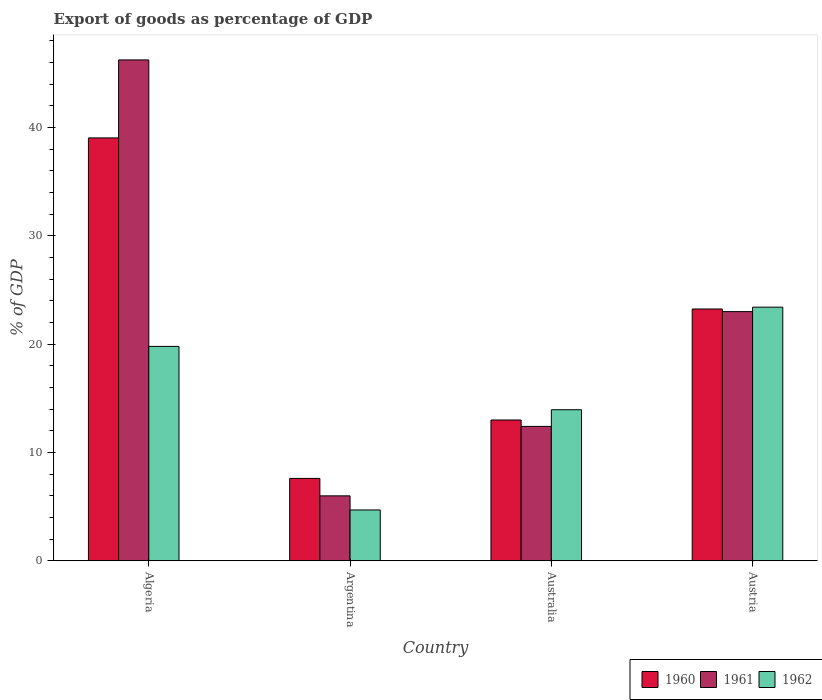How many different coloured bars are there?
Make the answer very short. 3. How many groups of bars are there?
Offer a terse response. 4. Are the number of bars per tick equal to the number of legend labels?
Provide a succinct answer. Yes. Are the number of bars on each tick of the X-axis equal?
Give a very brief answer. Yes. How many bars are there on the 4th tick from the right?
Keep it short and to the point. 3. What is the label of the 1st group of bars from the left?
Make the answer very short. Algeria. What is the export of goods as percentage of GDP in 1961 in Austria?
Ensure brevity in your answer.  23.01. Across all countries, what is the maximum export of goods as percentage of GDP in 1960?
Offer a terse response. 39.04. Across all countries, what is the minimum export of goods as percentage of GDP in 1960?
Keep it short and to the point. 7.6. In which country was the export of goods as percentage of GDP in 1960 maximum?
Offer a very short reply. Algeria. What is the total export of goods as percentage of GDP in 1961 in the graph?
Your response must be concise. 87.65. What is the difference between the export of goods as percentage of GDP in 1960 in Australia and that in Austria?
Make the answer very short. -10.25. What is the difference between the export of goods as percentage of GDP in 1960 in Australia and the export of goods as percentage of GDP in 1962 in Austria?
Make the answer very short. -10.42. What is the average export of goods as percentage of GDP in 1962 per country?
Your answer should be compact. 15.46. What is the difference between the export of goods as percentage of GDP of/in 1961 and export of goods as percentage of GDP of/in 1960 in Algeria?
Offer a terse response. 7.2. In how many countries, is the export of goods as percentage of GDP in 1960 greater than 16 %?
Provide a short and direct response. 2. What is the ratio of the export of goods as percentage of GDP in 1961 in Algeria to that in Austria?
Your answer should be very brief. 2.01. Is the export of goods as percentage of GDP in 1961 in Argentina less than that in Austria?
Your answer should be compact. Yes. Is the difference between the export of goods as percentage of GDP in 1961 in Australia and Austria greater than the difference between the export of goods as percentage of GDP in 1960 in Australia and Austria?
Offer a very short reply. No. What is the difference between the highest and the second highest export of goods as percentage of GDP in 1962?
Your response must be concise. 5.85. What is the difference between the highest and the lowest export of goods as percentage of GDP in 1961?
Offer a very short reply. 40.25. In how many countries, is the export of goods as percentage of GDP in 1962 greater than the average export of goods as percentage of GDP in 1962 taken over all countries?
Provide a short and direct response. 2. Is the sum of the export of goods as percentage of GDP in 1961 in Algeria and Australia greater than the maximum export of goods as percentage of GDP in 1962 across all countries?
Provide a short and direct response. Yes. What does the 3rd bar from the left in Argentina represents?
Ensure brevity in your answer.  1962. Is it the case that in every country, the sum of the export of goods as percentage of GDP in 1961 and export of goods as percentage of GDP in 1960 is greater than the export of goods as percentage of GDP in 1962?
Make the answer very short. Yes. How many bars are there?
Offer a terse response. 12. Are all the bars in the graph horizontal?
Make the answer very short. No. How many countries are there in the graph?
Make the answer very short. 4. Are the values on the major ticks of Y-axis written in scientific E-notation?
Your answer should be very brief. No. Does the graph contain grids?
Provide a short and direct response. No. Where does the legend appear in the graph?
Your answer should be compact. Bottom right. How many legend labels are there?
Ensure brevity in your answer.  3. How are the legend labels stacked?
Provide a succinct answer. Horizontal. What is the title of the graph?
Give a very brief answer. Export of goods as percentage of GDP. What is the label or title of the X-axis?
Provide a succinct answer. Country. What is the label or title of the Y-axis?
Give a very brief answer. % of GDP. What is the % of GDP in 1960 in Algeria?
Provide a short and direct response. 39.04. What is the % of GDP of 1961 in Algeria?
Provide a short and direct response. 46.24. What is the % of GDP of 1962 in Algeria?
Ensure brevity in your answer.  19.79. What is the % of GDP in 1960 in Argentina?
Your answer should be compact. 7.6. What is the % of GDP of 1961 in Argentina?
Ensure brevity in your answer.  5.99. What is the % of GDP of 1962 in Argentina?
Make the answer very short. 4.69. What is the % of GDP in 1960 in Australia?
Offer a very short reply. 13. What is the % of GDP in 1961 in Australia?
Keep it short and to the point. 12.41. What is the % of GDP of 1962 in Australia?
Your response must be concise. 13.95. What is the % of GDP in 1960 in Austria?
Make the answer very short. 23.25. What is the % of GDP of 1961 in Austria?
Give a very brief answer. 23.01. What is the % of GDP of 1962 in Austria?
Provide a short and direct response. 23.42. Across all countries, what is the maximum % of GDP of 1960?
Offer a terse response. 39.04. Across all countries, what is the maximum % of GDP of 1961?
Offer a terse response. 46.24. Across all countries, what is the maximum % of GDP of 1962?
Keep it short and to the point. 23.42. Across all countries, what is the minimum % of GDP in 1960?
Your answer should be compact. 7.6. Across all countries, what is the minimum % of GDP in 1961?
Your answer should be very brief. 5.99. Across all countries, what is the minimum % of GDP in 1962?
Provide a succinct answer. 4.69. What is the total % of GDP in 1960 in the graph?
Provide a short and direct response. 82.89. What is the total % of GDP in 1961 in the graph?
Your response must be concise. 87.65. What is the total % of GDP of 1962 in the graph?
Your answer should be very brief. 61.85. What is the difference between the % of GDP in 1960 in Algeria and that in Argentina?
Make the answer very short. 31.44. What is the difference between the % of GDP in 1961 in Algeria and that in Argentina?
Offer a terse response. 40.25. What is the difference between the % of GDP of 1962 in Algeria and that in Argentina?
Make the answer very short. 15.1. What is the difference between the % of GDP in 1960 in Algeria and that in Australia?
Provide a short and direct response. 26.04. What is the difference between the % of GDP of 1961 in Algeria and that in Australia?
Offer a very short reply. 33.84. What is the difference between the % of GDP in 1962 in Algeria and that in Australia?
Give a very brief answer. 5.85. What is the difference between the % of GDP in 1960 in Algeria and that in Austria?
Your answer should be compact. 15.8. What is the difference between the % of GDP of 1961 in Algeria and that in Austria?
Ensure brevity in your answer.  23.24. What is the difference between the % of GDP of 1962 in Algeria and that in Austria?
Provide a succinct answer. -3.62. What is the difference between the % of GDP of 1960 in Argentina and that in Australia?
Your answer should be compact. -5.39. What is the difference between the % of GDP of 1961 in Argentina and that in Australia?
Offer a very short reply. -6.41. What is the difference between the % of GDP in 1962 in Argentina and that in Australia?
Ensure brevity in your answer.  -9.25. What is the difference between the % of GDP in 1960 in Argentina and that in Austria?
Give a very brief answer. -15.64. What is the difference between the % of GDP in 1961 in Argentina and that in Austria?
Your response must be concise. -17.01. What is the difference between the % of GDP of 1962 in Argentina and that in Austria?
Make the answer very short. -18.72. What is the difference between the % of GDP of 1960 in Australia and that in Austria?
Offer a terse response. -10.25. What is the difference between the % of GDP of 1961 in Australia and that in Austria?
Your response must be concise. -10.6. What is the difference between the % of GDP in 1962 in Australia and that in Austria?
Provide a succinct answer. -9.47. What is the difference between the % of GDP of 1960 in Algeria and the % of GDP of 1961 in Argentina?
Give a very brief answer. 33.05. What is the difference between the % of GDP in 1960 in Algeria and the % of GDP in 1962 in Argentina?
Make the answer very short. 34.35. What is the difference between the % of GDP of 1961 in Algeria and the % of GDP of 1962 in Argentina?
Provide a short and direct response. 41.55. What is the difference between the % of GDP of 1960 in Algeria and the % of GDP of 1961 in Australia?
Your answer should be very brief. 26.63. What is the difference between the % of GDP of 1960 in Algeria and the % of GDP of 1962 in Australia?
Give a very brief answer. 25.1. What is the difference between the % of GDP of 1961 in Algeria and the % of GDP of 1962 in Australia?
Make the answer very short. 32.3. What is the difference between the % of GDP in 1960 in Algeria and the % of GDP in 1961 in Austria?
Offer a terse response. 16.04. What is the difference between the % of GDP of 1960 in Algeria and the % of GDP of 1962 in Austria?
Ensure brevity in your answer.  15.63. What is the difference between the % of GDP of 1961 in Algeria and the % of GDP of 1962 in Austria?
Offer a very short reply. 22.83. What is the difference between the % of GDP in 1960 in Argentina and the % of GDP in 1961 in Australia?
Offer a terse response. -4.8. What is the difference between the % of GDP in 1960 in Argentina and the % of GDP in 1962 in Australia?
Give a very brief answer. -6.34. What is the difference between the % of GDP in 1961 in Argentina and the % of GDP in 1962 in Australia?
Give a very brief answer. -7.95. What is the difference between the % of GDP in 1960 in Argentina and the % of GDP in 1961 in Austria?
Offer a very short reply. -15.4. What is the difference between the % of GDP in 1960 in Argentina and the % of GDP in 1962 in Austria?
Your answer should be compact. -15.81. What is the difference between the % of GDP of 1961 in Argentina and the % of GDP of 1962 in Austria?
Provide a succinct answer. -17.42. What is the difference between the % of GDP of 1960 in Australia and the % of GDP of 1961 in Austria?
Ensure brevity in your answer.  -10.01. What is the difference between the % of GDP in 1960 in Australia and the % of GDP in 1962 in Austria?
Your answer should be compact. -10.42. What is the difference between the % of GDP of 1961 in Australia and the % of GDP of 1962 in Austria?
Keep it short and to the point. -11.01. What is the average % of GDP of 1960 per country?
Give a very brief answer. 20.72. What is the average % of GDP of 1961 per country?
Your answer should be compact. 21.91. What is the average % of GDP in 1962 per country?
Ensure brevity in your answer.  15.46. What is the difference between the % of GDP of 1960 and % of GDP of 1961 in Algeria?
Ensure brevity in your answer.  -7.2. What is the difference between the % of GDP in 1960 and % of GDP in 1962 in Algeria?
Provide a short and direct response. 19.25. What is the difference between the % of GDP of 1961 and % of GDP of 1962 in Algeria?
Your answer should be compact. 26.45. What is the difference between the % of GDP of 1960 and % of GDP of 1961 in Argentina?
Give a very brief answer. 1.61. What is the difference between the % of GDP of 1960 and % of GDP of 1962 in Argentina?
Provide a short and direct response. 2.91. What is the difference between the % of GDP of 1961 and % of GDP of 1962 in Argentina?
Your response must be concise. 1.3. What is the difference between the % of GDP of 1960 and % of GDP of 1961 in Australia?
Keep it short and to the point. 0.59. What is the difference between the % of GDP in 1960 and % of GDP in 1962 in Australia?
Your answer should be compact. -0.95. What is the difference between the % of GDP of 1961 and % of GDP of 1962 in Australia?
Ensure brevity in your answer.  -1.54. What is the difference between the % of GDP in 1960 and % of GDP in 1961 in Austria?
Keep it short and to the point. 0.24. What is the difference between the % of GDP in 1960 and % of GDP in 1962 in Austria?
Offer a very short reply. -0.17. What is the difference between the % of GDP of 1961 and % of GDP of 1962 in Austria?
Your response must be concise. -0.41. What is the ratio of the % of GDP in 1960 in Algeria to that in Argentina?
Ensure brevity in your answer.  5.13. What is the ratio of the % of GDP in 1961 in Algeria to that in Argentina?
Keep it short and to the point. 7.71. What is the ratio of the % of GDP of 1962 in Algeria to that in Argentina?
Give a very brief answer. 4.22. What is the ratio of the % of GDP of 1960 in Algeria to that in Australia?
Offer a very short reply. 3. What is the ratio of the % of GDP in 1961 in Algeria to that in Australia?
Provide a short and direct response. 3.73. What is the ratio of the % of GDP of 1962 in Algeria to that in Australia?
Ensure brevity in your answer.  1.42. What is the ratio of the % of GDP in 1960 in Algeria to that in Austria?
Offer a terse response. 1.68. What is the ratio of the % of GDP in 1961 in Algeria to that in Austria?
Make the answer very short. 2.01. What is the ratio of the % of GDP in 1962 in Algeria to that in Austria?
Your answer should be compact. 0.85. What is the ratio of the % of GDP of 1960 in Argentina to that in Australia?
Provide a short and direct response. 0.58. What is the ratio of the % of GDP of 1961 in Argentina to that in Australia?
Offer a terse response. 0.48. What is the ratio of the % of GDP in 1962 in Argentina to that in Australia?
Provide a succinct answer. 0.34. What is the ratio of the % of GDP in 1960 in Argentina to that in Austria?
Ensure brevity in your answer.  0.33. What is the ratio of the % of GDP in 1961 in Argentina to that in Austria?
Your response must be concise. 0.26. What is the ratio of the % of GDP in 1962 in Argentina to that in Austria?
Make the answer very short. 0.2. What is the ratio of the % of GDP in 1960 in Australia to that in Austria?
Keep it short and to the point. 0.56. What is the ratio of the % of GDP in 1961 in Australia to that in Austria?
Your response must be concise. 0.54. What is the ratio of the % of GDP of 1962 in Australia to that in Austria?
Give a very brief answer. 0.6. What is the difference between the highest and the second highest % of GDP in 1960?
Your answer should be compact. 15.8. What is the difference between the highest and the second highest % of GDP of 1961?
Offer a terse response. 23.24. What is the difference between the highest and the second highest % of GDP in 1962?
Provide a succinct answer. 3.62. What is the difference between the highest and the lowest % of GDP in 1960?
Your answer should be compact. 31.44. What is the difference between the highest and the lowest % of GDP of 1961?
Offer a very short reply. 40.25. What is the difference between the highest and the lowest % of GDP of 1962?
Keep it short and to the point. 18.72. 